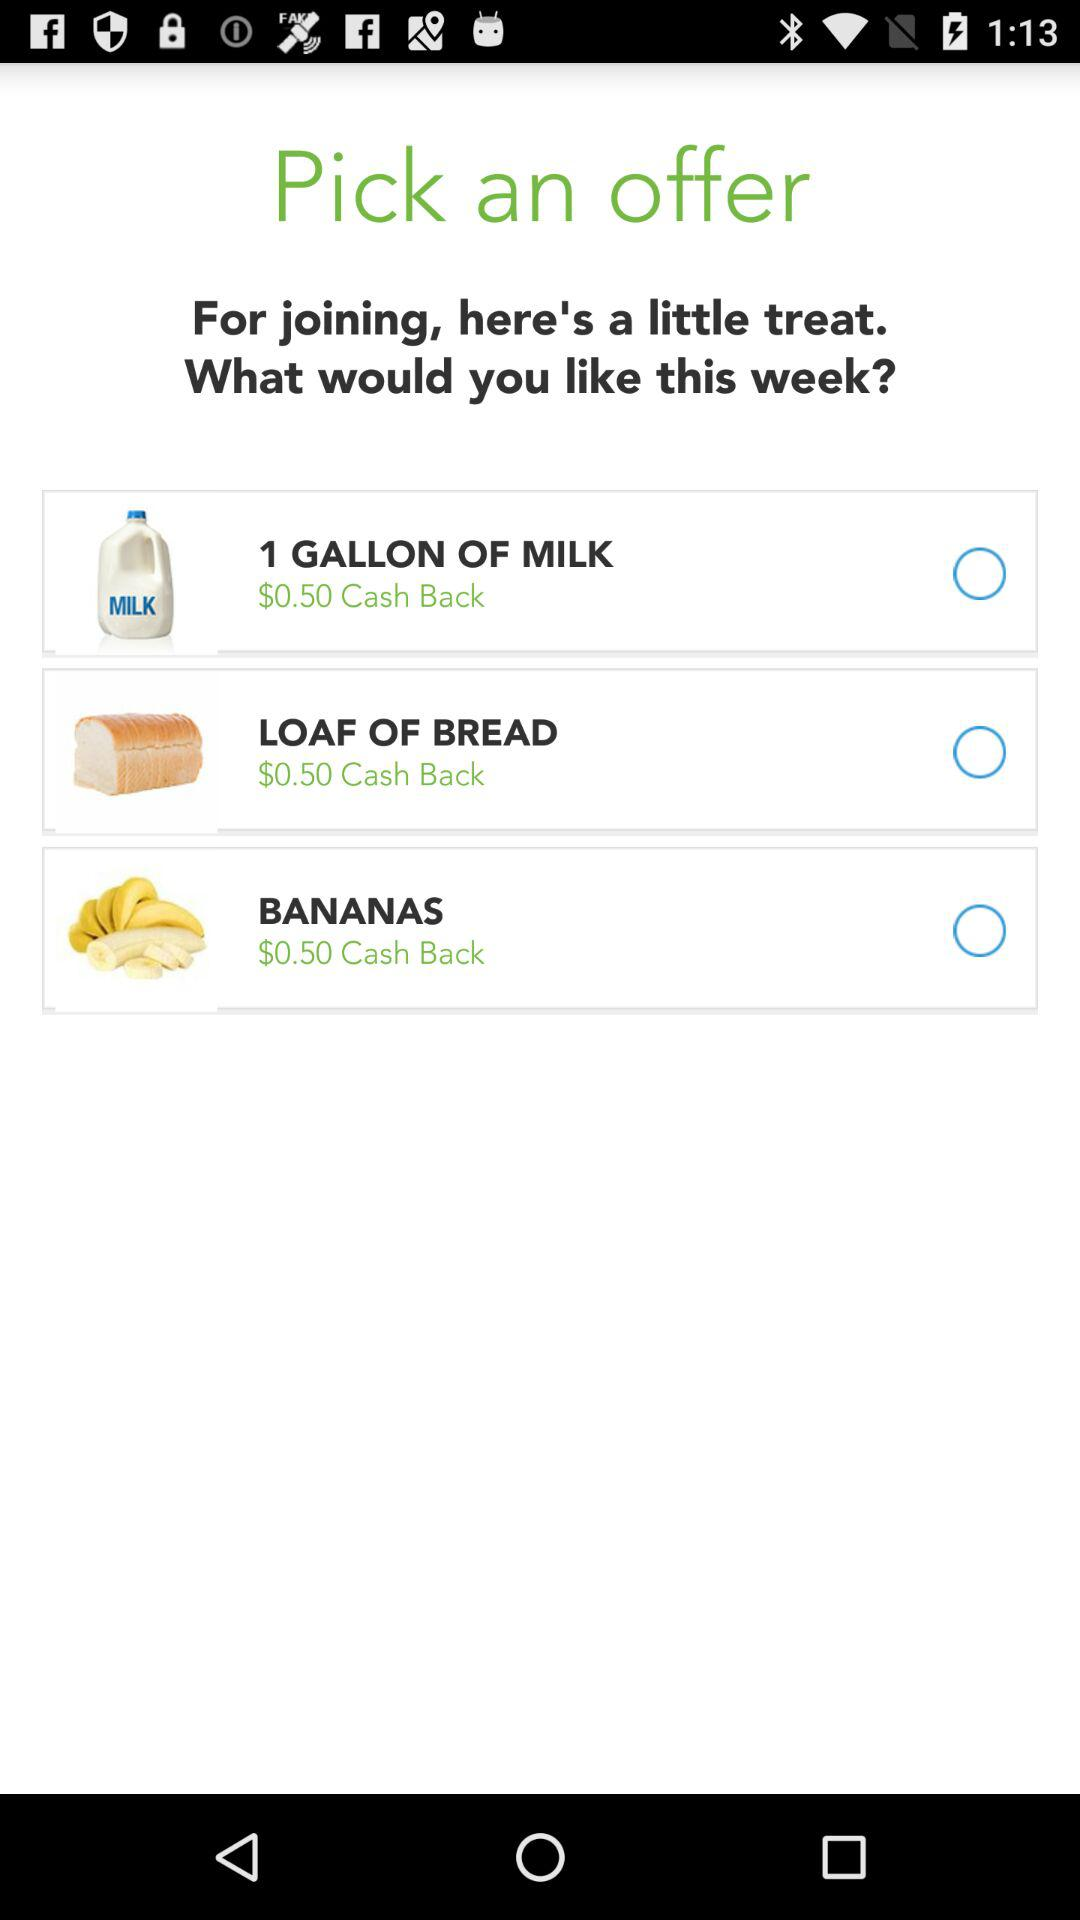What is the currency of cash back? The currency of cash back is $. 